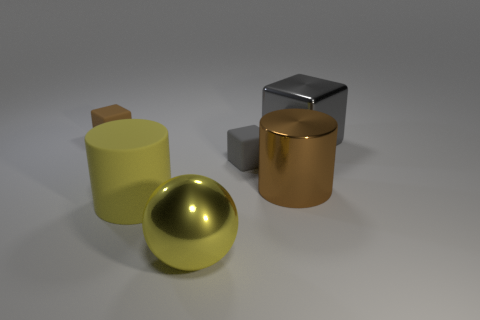What materials do the objects seem to be made of? The objects appear to have different materials. The yellow cylinder and the sphere have a glossy finish suggesting they might be made of polished metal. The cube and the other cylinder have a matte finish, which could indicate a ceramic or plastic material. 